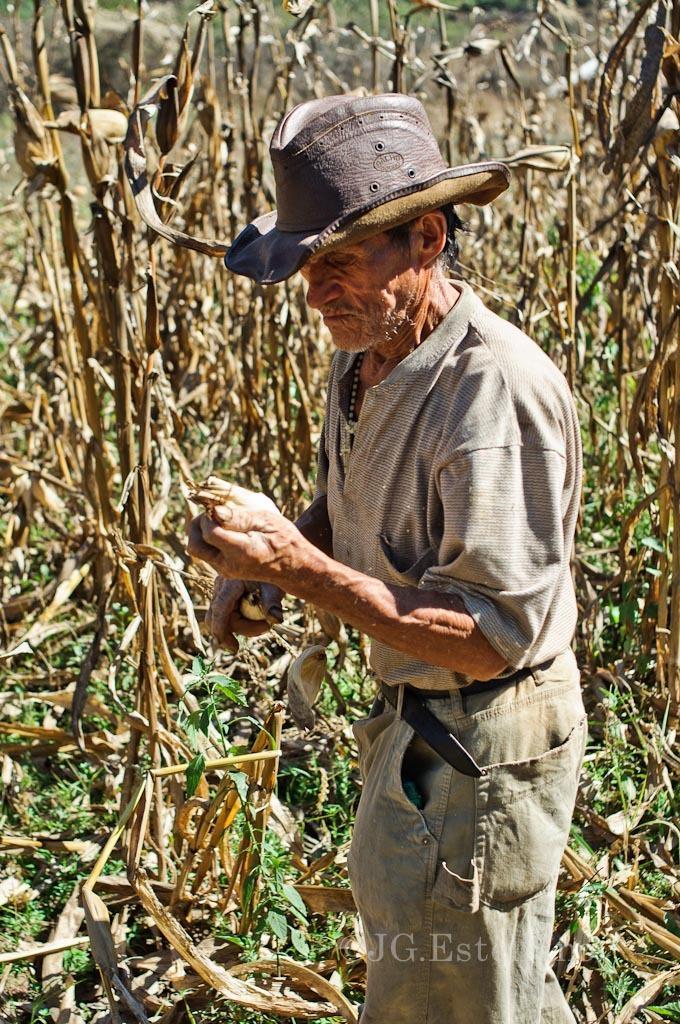Please provide a concise description of this image. In this picture there is a person standing and wearing a hat on his head and there are some other beside him. 